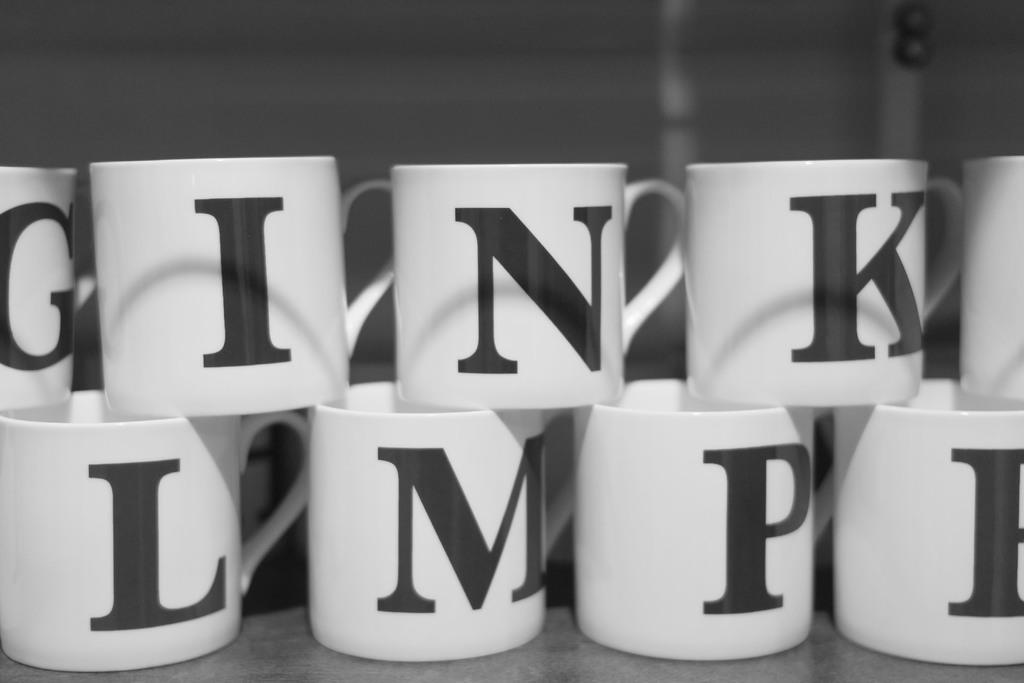<image>
Share a concise interpretation of the image provided. Cups stacked on top of one another including one that has the letter M on it. 